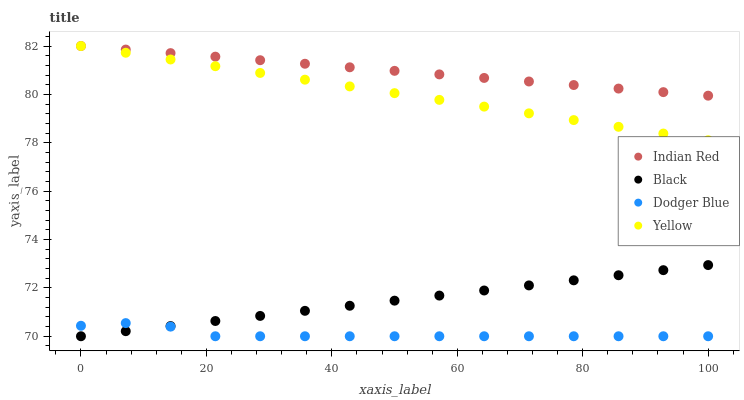Does Dodger Blue have the minimum area under the curve?
Answer yes or no. Yes. Does Indian Red have the maximum area under the curve?
Answer yes or no. Yes. Does Black have the minimum area under the curve?
Answer yes or no. No. Does Black have the maximum area under the curve?
Answer yes or no. No. Is Black the smoothest?
Answer yes or no. Yes. Is Dodger Blue the roughest?
Answer yes or no. Yes. Is Yellow the smoothest?
Answer yes or no. No. Is Yellow the roughest?
Answer yes or no. No. Does Dodger Blue have the lowest value?
Answer yes or no. Yes. Does Yellow have the lowest value?
Answer yes or no. No. Does Indian Red have the highest value?
Answer yes or no. Yes. Does Black have the highest value?
Answer yes or no. No. Is Black less than Yellow?
Answer yes or no. Yes. Is Yellow greater than Black?
Answer yes or no. Yes. Does Black intersect Dodger Blue?
Answer yes or no. Yes. Is Black less than Dodger Blue?
Answer yes or no. No. Is Black greater than Dodger Blue?
Answer yes or no. No. Does Black intersect Yellow?
Answer yes or no. No. 